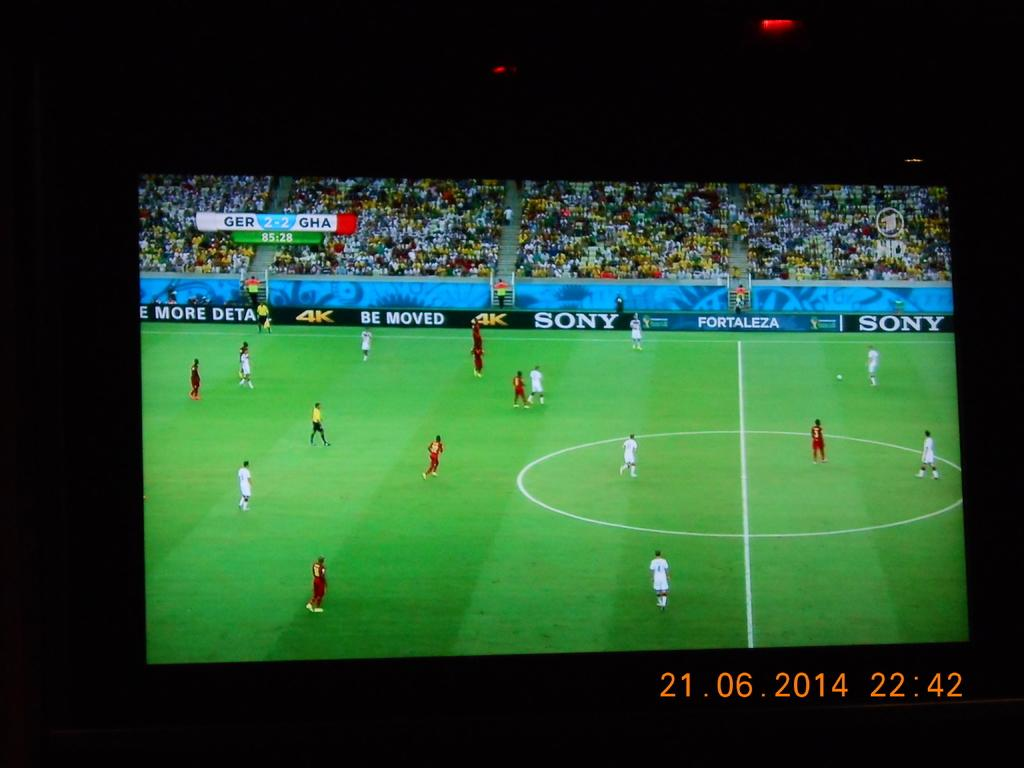<image>
Relay a brief, clear account of the picture shown. Germany and Ghana playing a soccer match with a time stamp on it. 